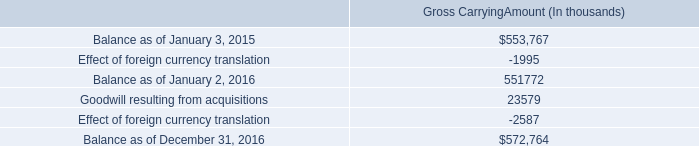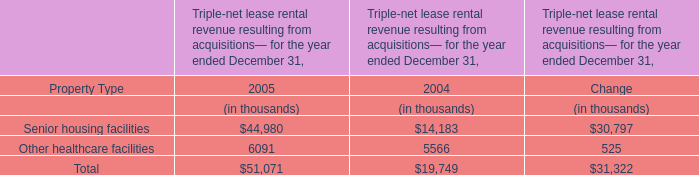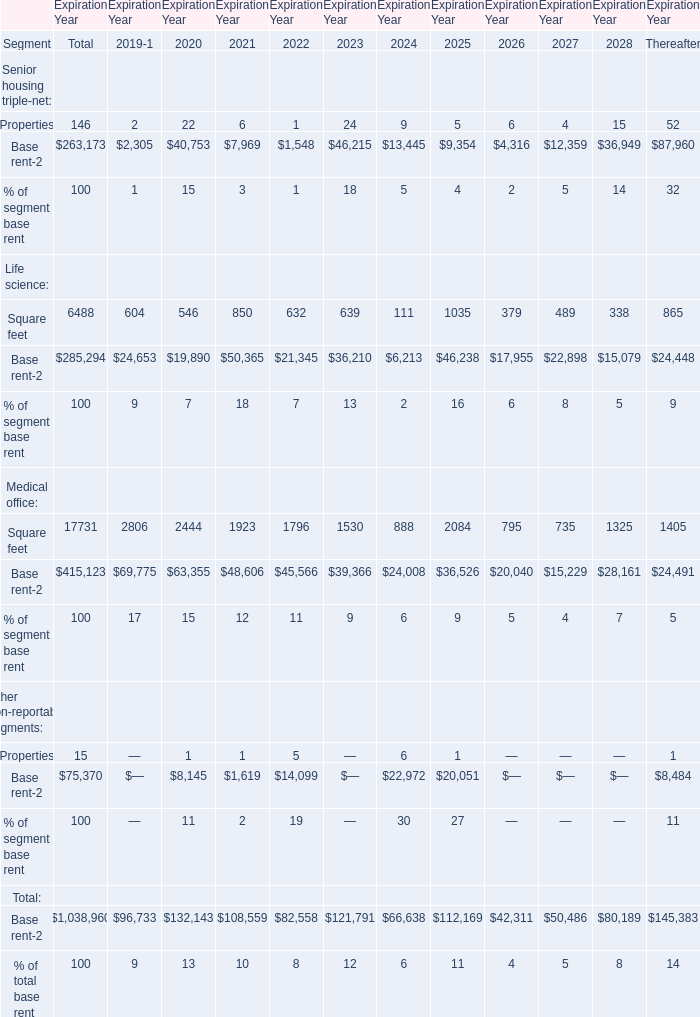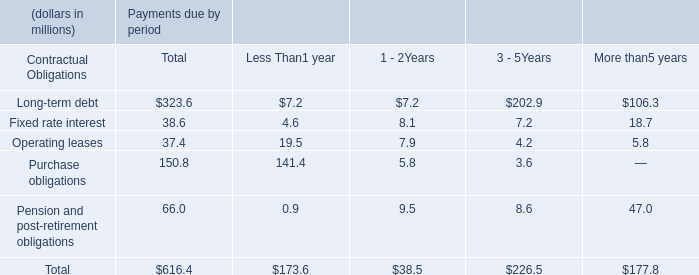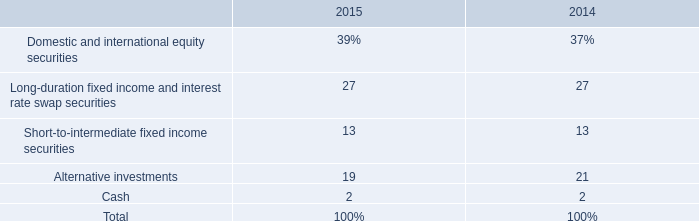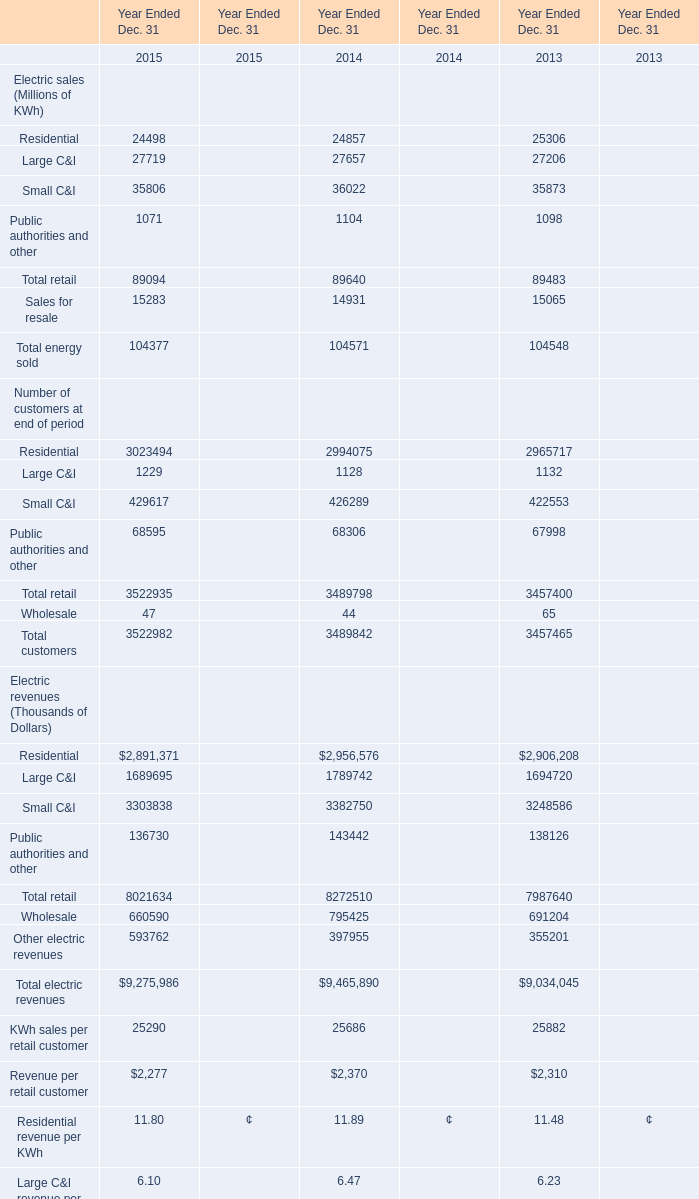In the year with largest amount of Properties , what's the increasing rate of Square feet? 
Computations: ((639 - 632) / 639)
Answer: 0.01095. 